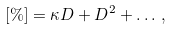Convert formula to latex. <formula><loc_0><loc_0><loc_500><loc_500>[ \% ] = \kappa D + D ^ { 2 } + \dots \, ,</formula> 